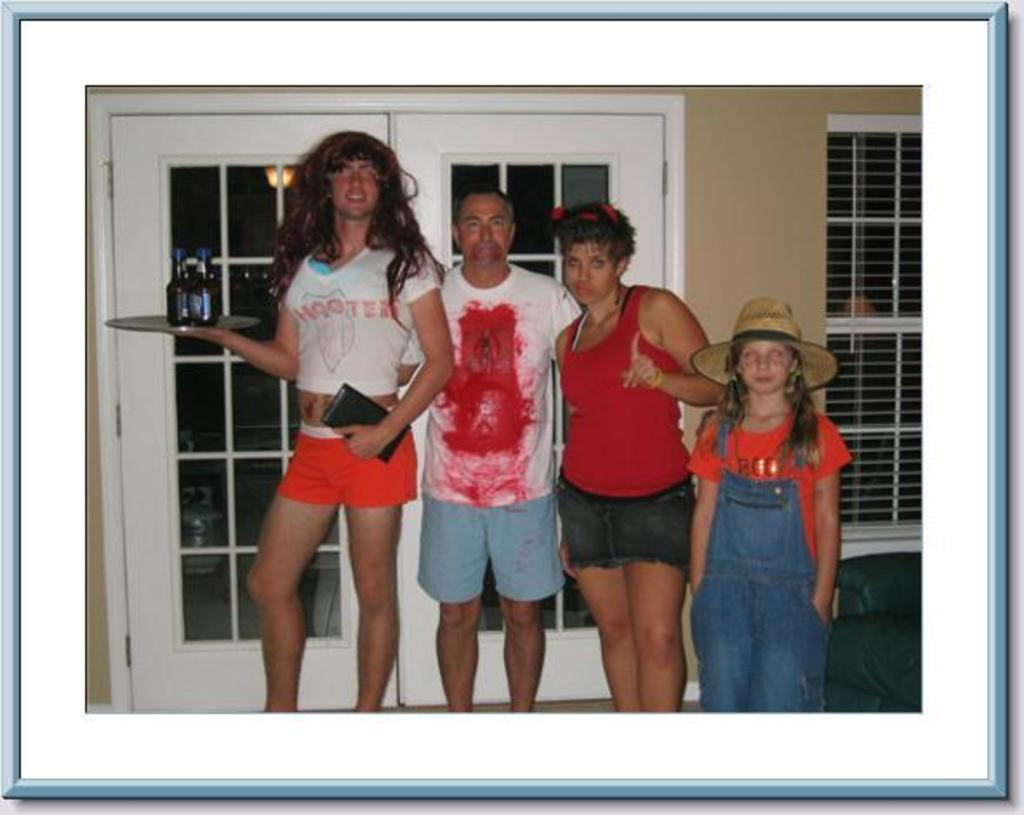<image>
Summarize the visual content of the image. The person on the left is dressed up in a Hooters t-shirt. 